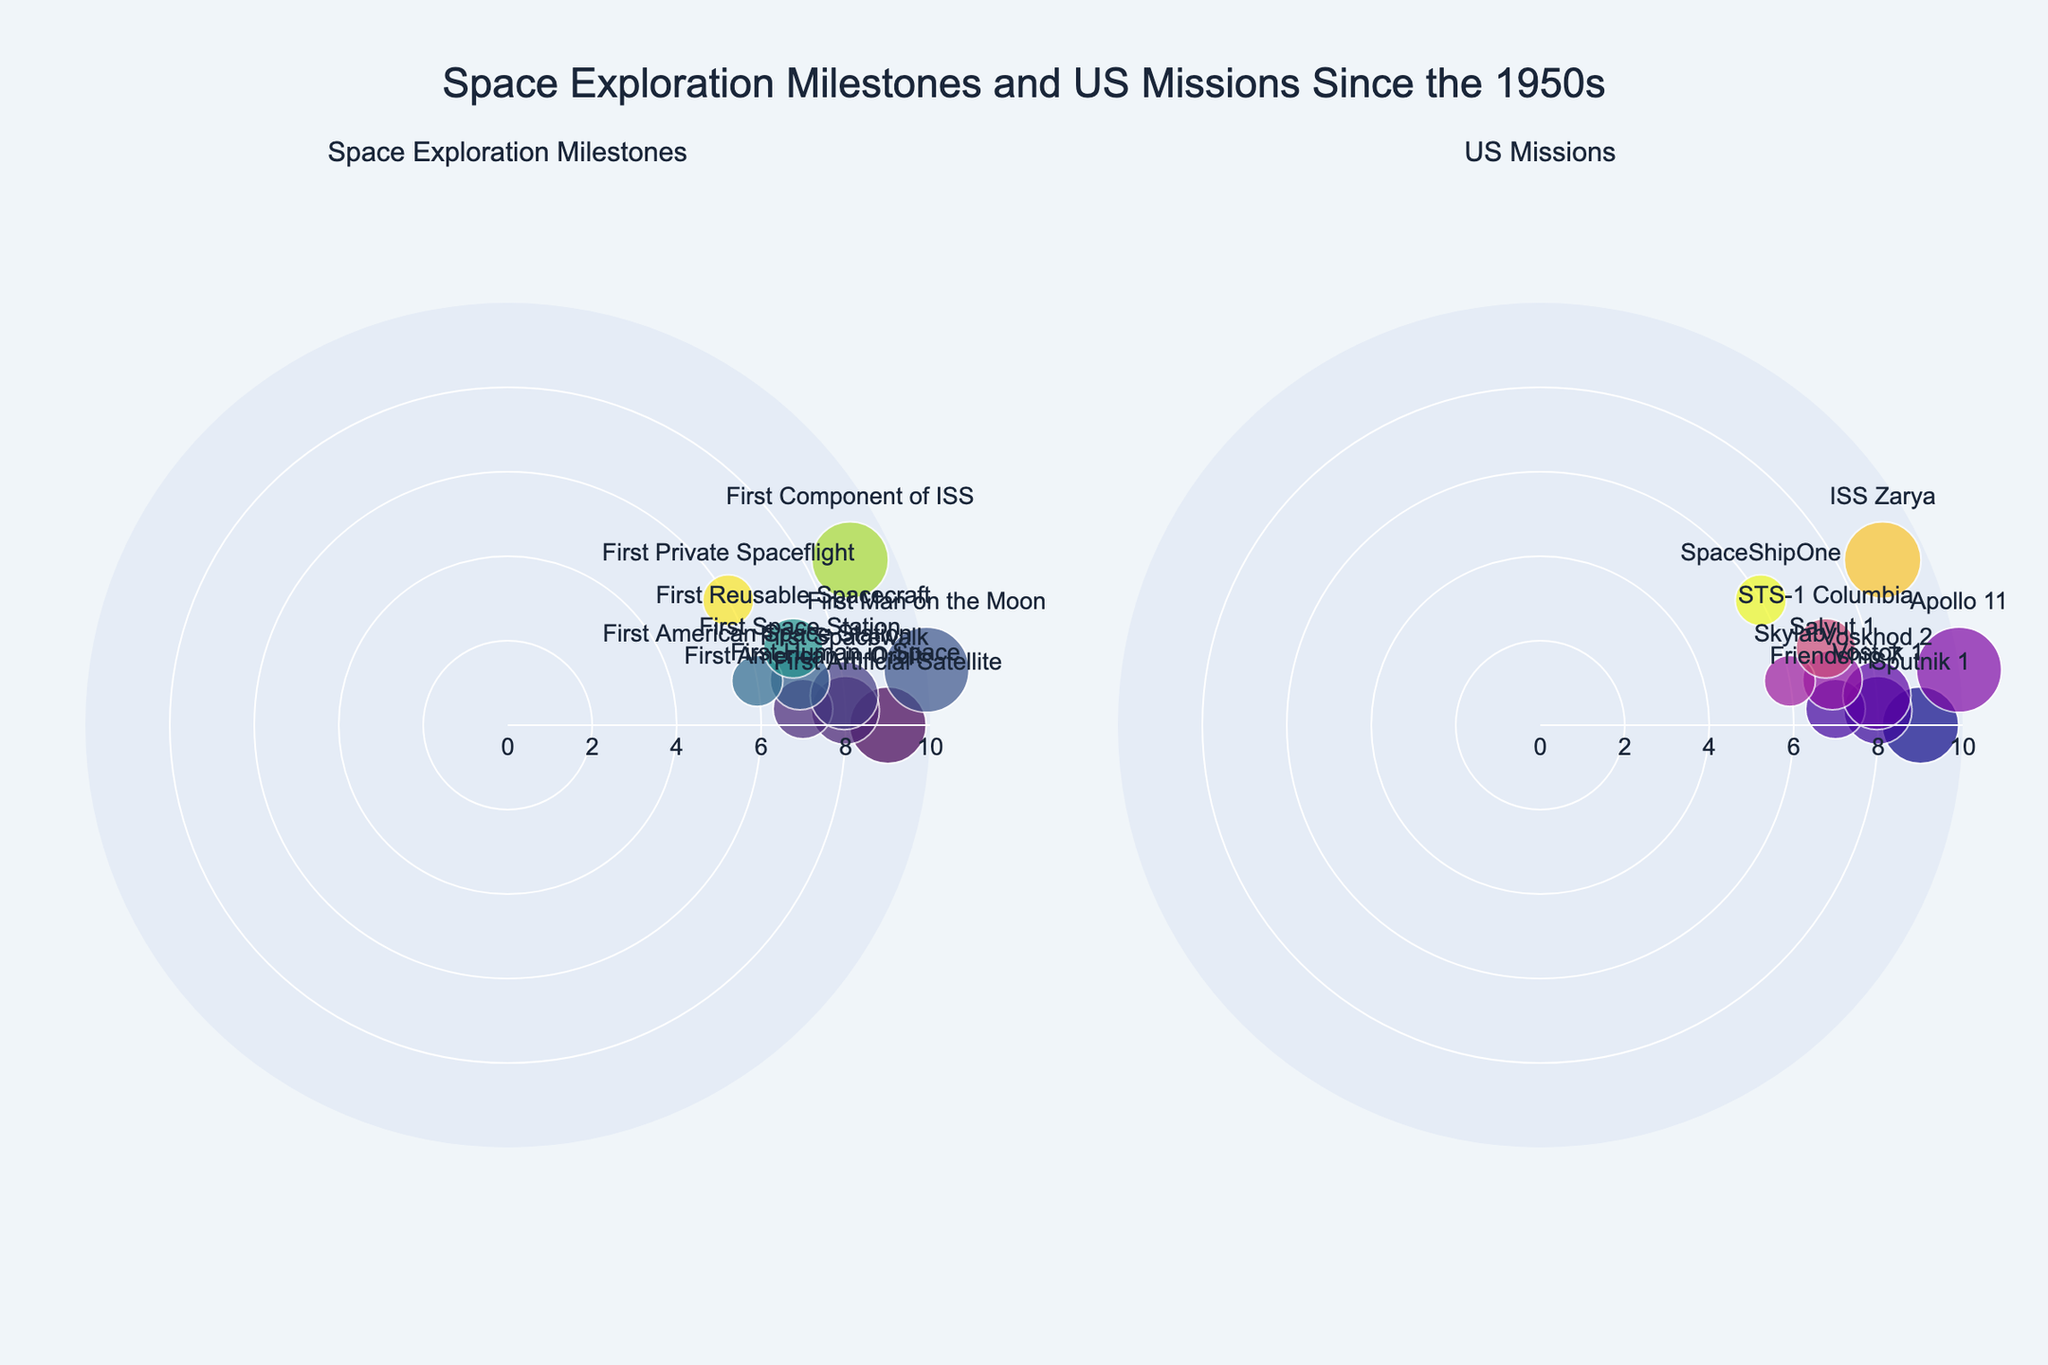What's the title of the figure? The title is displayed at the top-center of the figure in a larger font size; it reads "Space Exploration Milestones and US Missions Since the 1950s."
Answer: Space Exploration Milestones and US Missions Since the 1950s How many data points are shown in the first subplot? The first subplot titled "Space Exploration Milestones" displays each milestone data point, and there are a total of 10 data points.
Answer: 10 Which milestone has the highest impact score and in what year did it occur? The milestone with the highest impact score is depicted by the largest marker in the plot. The milestone "First Man on the Moon" in 1969 has the highest impact score of 10.
Answer: First Man on the Moon, 1969 How many US missions since the 1950s are shown in the second subplot? The second subplot titled "US Missions" showcases each mission data point, totaling 5 US missions.
Answer: 5 Which subplot has more data points, and by how many? From counting the data points in both subplots, the first subplot "Space Exploration Milestones" has 10 data points, whereas the second subplot "US Missions" has 5 data points. Therefore, the first subplot has more data points by 5.
Answer: First subplot by 5 What is the average impact score of the milestones? To find the average impact score, sum the impact scores of all milestones (9+8+7+8+10+7+6+7+9+6) which equals 77. There are 10 milestones, so the average is 77/10.
Answer: 7.7 Which mission marked the start of the ISS and what is its impact score? In the "US Missions" subplot, the mission related to the ISS is "ISS Zarya" recorded in 1998 with an impact score of 9.
Answer: ISS Zarya, 9 Between the first milestone "Sputnik 1" and "Apollo 11", which has a higher impact score and by how much? "Sputnik 1" has an impact score of 9 while "Apollo 11" has an impact score of 10. The difference in impact score is 10 - 9.
Answer: Apollo 11 by 1 What color represents the milestone events in the first subplot? The milestone events in the first subplot are color-coded using the Viridis color scale, typically ranging in shades from blue to yellow.
Answer: Viridis colorscale in shades from blue to yellow What is the impact score of the first private spaceflight and when did it occur? The first private spaceflight, "SpaceShipOne," is marked in the figure with an impact score of 6 and occurred in June 2004.
Answer: 6, 2004 